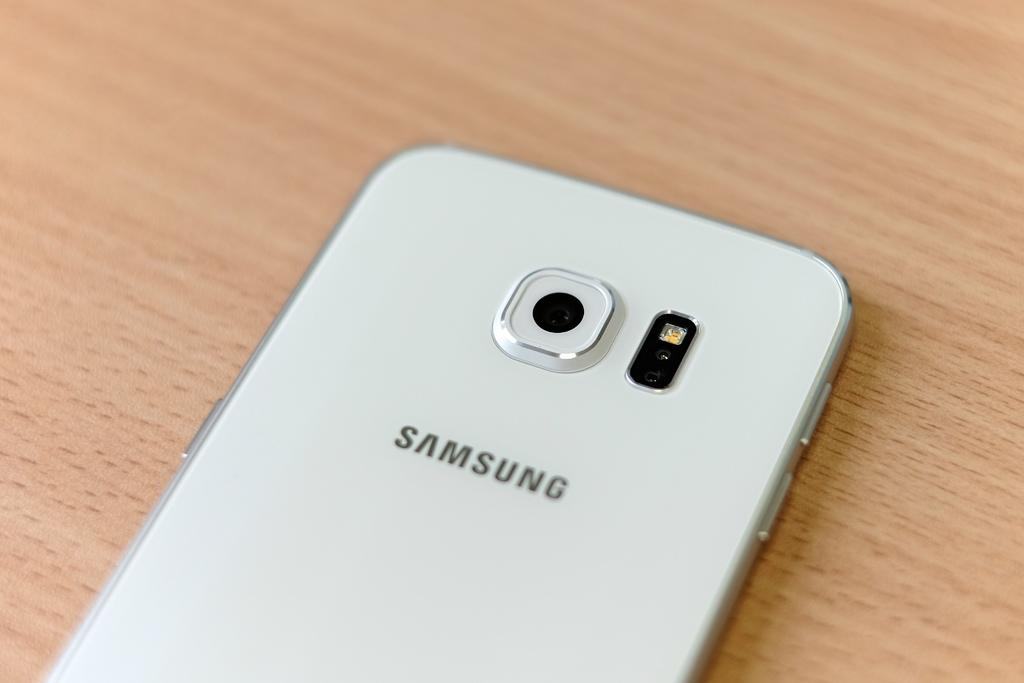<image>
Relay a brief, clear account of the picture shown. The back of a white Samsung phone is shown facing up. 